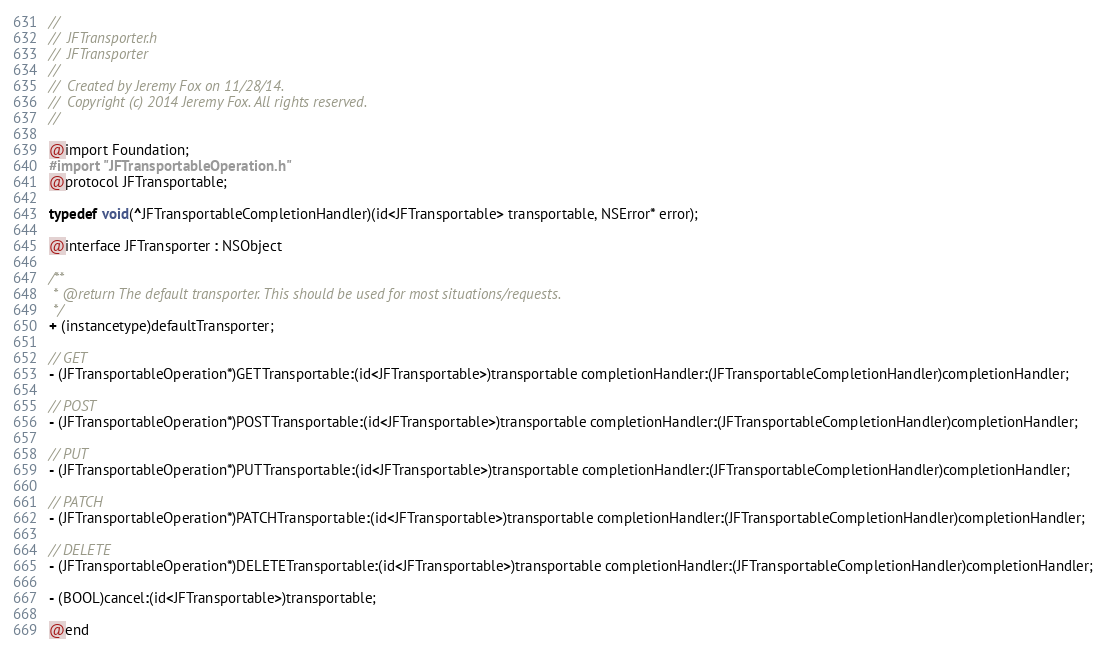<code> <loc_0><loc_0><loc_500><loc_500><_C_>//
//  JFTransporter.h
//  JFTransporter
//
//  Created by Jeremy Fox on 11/28/14.
//  Copyright (c) 2014 Jeremy Fox. All rights reserved.
//

@import Foundation;
#import "JFTransportableOperation.h"
@protocol JFTransportable;

typedef void(^JFTransportableCompletionHandler)(id<JFTransportable> transportable, NSError* error);

@interface JFTransporter : NSObject

/**
 * @return The default transporter. This should be used for most situations/requests.
 */
+ (instancetype)defaultTransporter;

// GET
- (JFTransportableOperation*)GETTransportable:(id<JFTransportable>)transportable completionHandler:(JFTransportableCompletionHandler)completionHandler;

// POST
- (JFTransportableOperation*)POSTTransportable:(id<JFTransportable>)transportable completionHandler:(JFTransportableCompletionHandler)completionHandler;

// PUT
- (JFTransportableOperation*)PUTTransportable:(id<JFTransportable>)transportable completionHandler:(JFTransportableCompletionHandler)completionHandler;

// PATCH
- (JFTransportableOperation*)PATCHTransportable:(id<JFTransportable>)transportable completionHandler:(JFTransportableCompletionHandler)completionHandler;

// DELETE
- (JFTransportableOperation*)DELETETransportable:(id<JFTransportable>)transportable completionHandler:(JFTransportableCompletionHandler)completionHandler;

- (BOOL)cancel:(id<JFTransportable>)transportable;

@end
</code> 